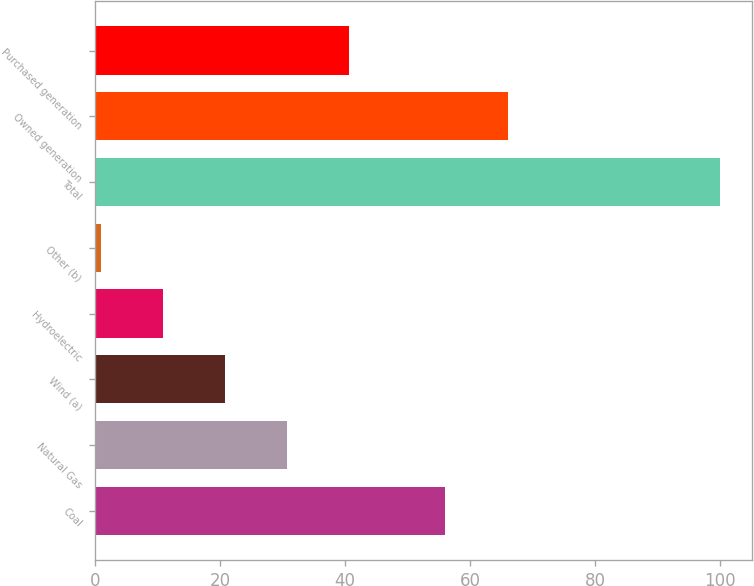Convert chart. <chart><loc_0><loc_0><loc_500><loc_500><bar_chart><fcel>Coal<fcel>Natural Gas<fcel>Wind (a)<fcel>Hydroelectric<fcel>Other (b)<fcel>Total<fcel>Owned generation<fcel>Purchased generation<nl><fcel>56<fcel>30.7<fcel>20.8<fcel>10.9<fcel>1<fcel>100<fcel>66<fcel>40.6<nl></chart> 